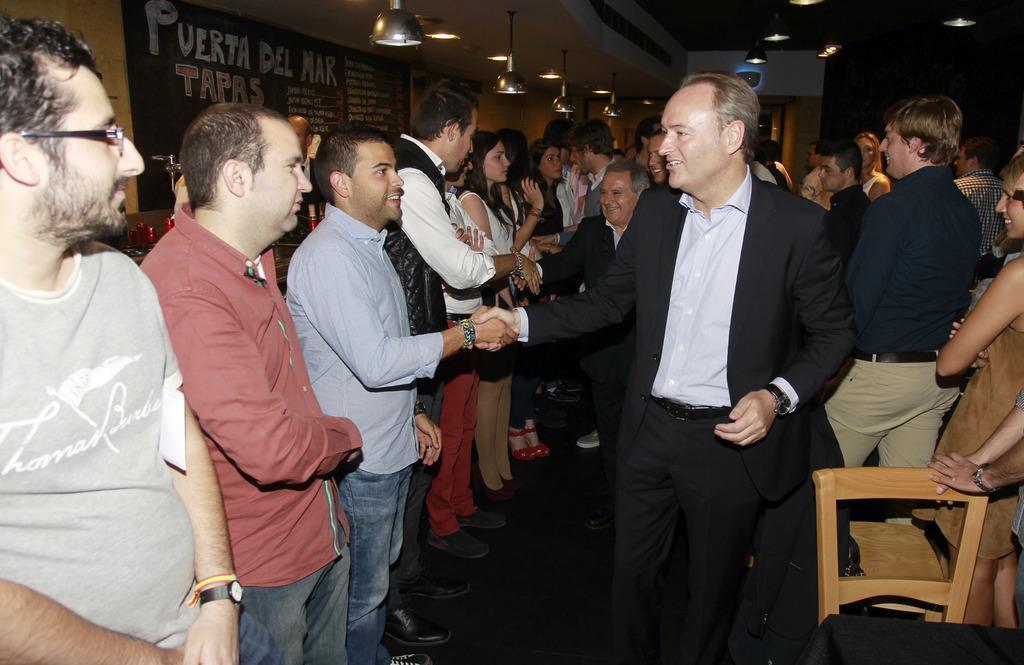How would you summarize this image in a sentence or two? In this picture there is a man who is wearing blazer, shirt, watch and trouser, he is shaking hands with a man who is wearing shirt, jeans and shoes. On the left there is a man who is wearing spectacle, t-shirt and watch, beside the bald man who is wearing a red shirt and jeans. In the bottom right corner we can see the woman who is standing near to the table and chair. In the background we can see many peoples were standing on the floor. At the top we can see many lights which is hanging from the roof. In the top left we can see the poster on the wall. 